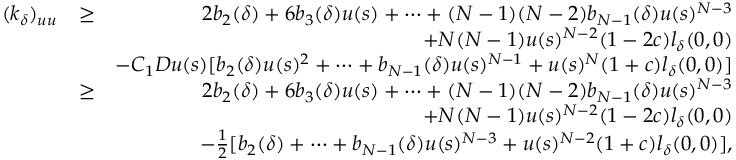Convert formula to latex. <formula><loc_0><loc_0><loc_500><loc_500>\begin{array} { r l r } { ( k _ { \delta } ) _ { u u } } & { \geq } & { 2 b _ { 2 } ( \delta ) + 6 b _ { 3 } ( \delta ) u ( s ) + \cdots + ( N - 1 ) ( N - 2 ) b _ { N - 1 } ( \delta ) u ( s ) ^ { N - 3 } } \\ & { + N ( N - 1 ) u ( s ) ^ { N - 2 } ( 1 - 2 c ) l _ { \delta } ( 0 , 0 ) } \\ & { - C _ { 1 } D u ( s ) [ b _ { 2 } ( \delta ) u ( s ) ^ { 2 } + \cdots + b _ { N - 1 } ( \delta ) u ( s ) ^ { N - 1 } + u ( s ) ^ { N } ( 1 + c ) l _ { \delta } ( 0 , 0 ) ] } \\ & { \geq } & { 2 b _ { 2 } ( \delta ) + 6 b _ { 3 } ( \delta ) u ( s ) + \cdots + ( N - 1 ) ( N - 2 ) b _ { N - 1 } ( \delta ) u ( s ) ^ { N - 3 } } \\ & { + N ( N - 1 ) u ( s ) ^ { N - 2 } ( 1 - 2 c ) l _ { \delta } ( 0 , 0 ) } \\ & { - \frac { 1 } { 2 } [ b _ { 2 } ( \delta ) + \cdots + b _ { N - 1 } ( \delta ) u ( s ) ^ { N - 3 } + u ( s ) ^ { N - 2 } ( 1 + c ) l _ { \delta } ( 0 , 0 ) ] , } \end{array}</formula> 